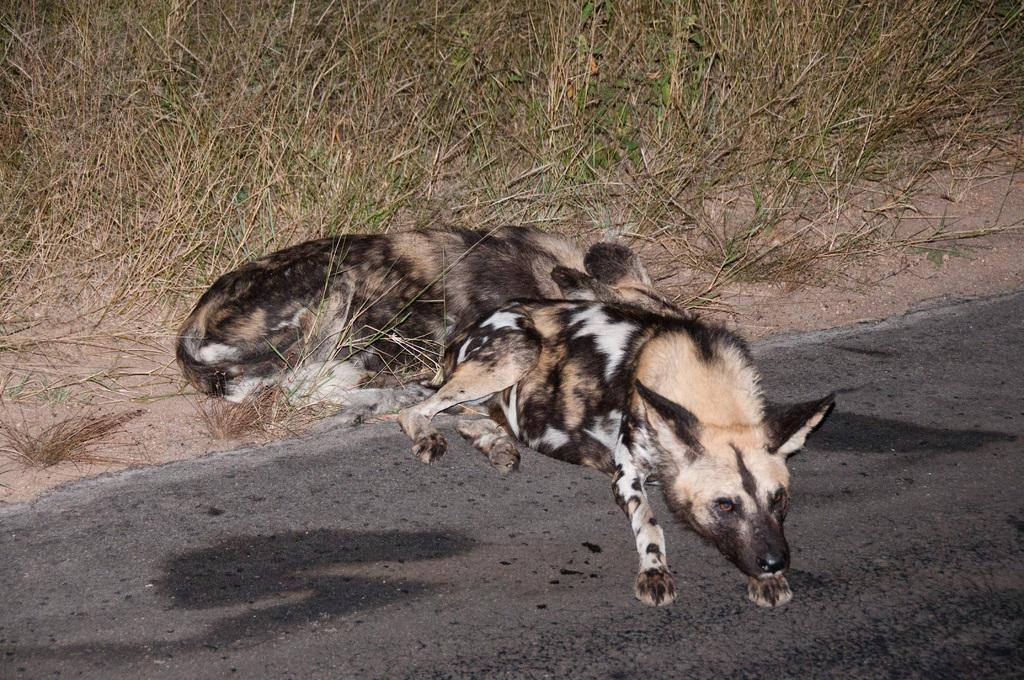What is the main subject of the image? The main subject of the image is a road. Are there any animals present in the image? Yes, there are two wolves in the image. Where is the first wolf located? The first wolf is sitting on the road. Where is the second wolf located? The second wolf is sitting on the grass in the background. Can you see any roses growing along the side of the road in the image? There are no roses visible in the image; it only features a road and two wolves. What memories might the wolves be reflecting on while sitting on the road and grass? The image does not provide any information about the wolves' thoughts or memories, so we cannot determine what they might be reflecting on. 